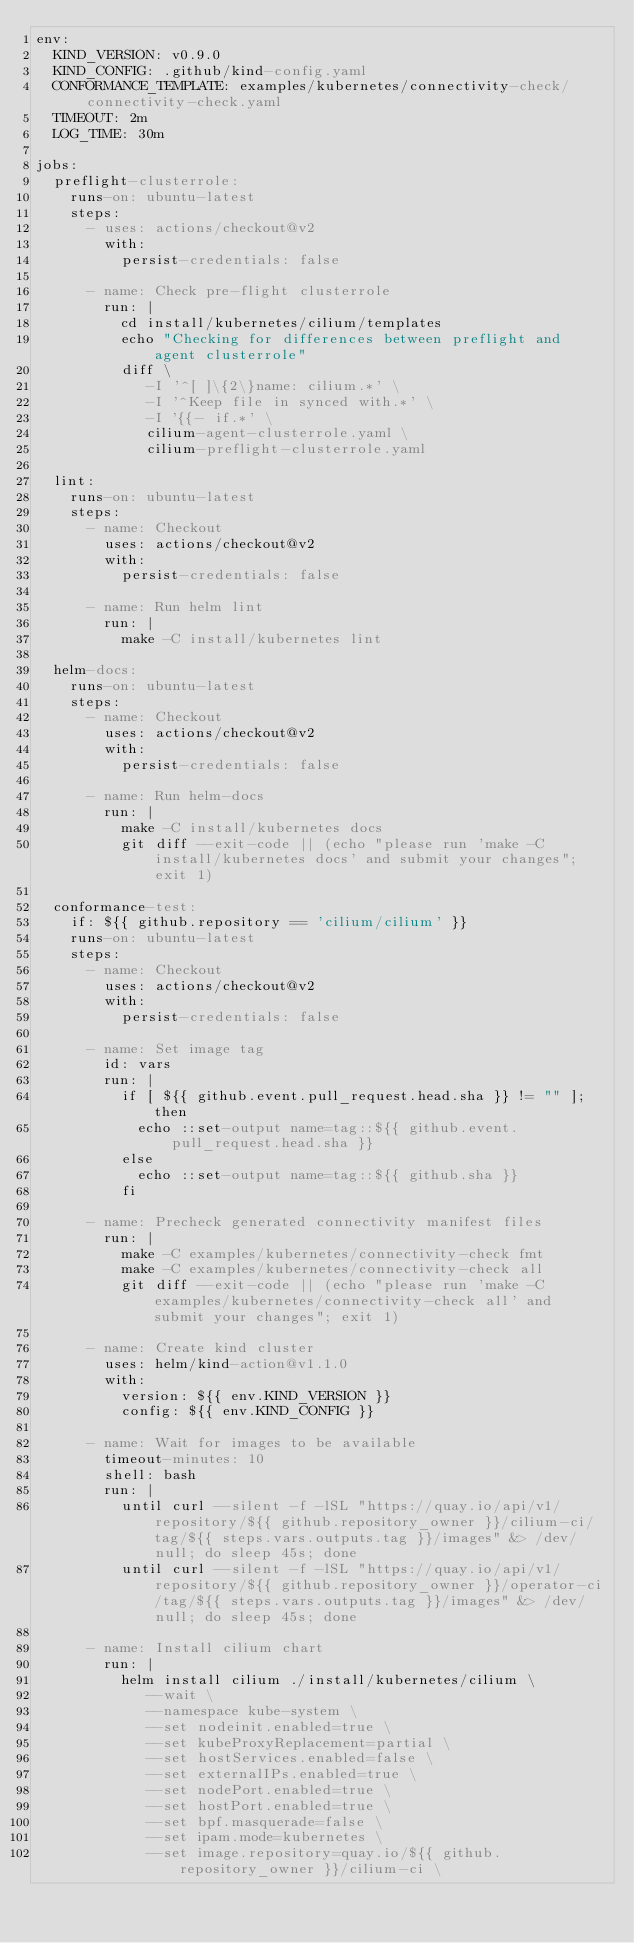<code> <loc_0><loc_0><loc_500><loc_500><_YAML_>env:
  KIND_VERSION: v0.9.0
  KIND_CONFIG: .github/kind-config.yaml
  CONFORMANCE_TEMPLATE: examples/kubernetes/connectivity-check/connectivity-check.yaml
  TIMEOUT: 2m
  LOG_TIME: 30m

jobs:
  preflight-clusterrole:
    runs-on: ubuntu-latest
    steps:
      - uses: actions/checkout@v2
        with:
          persist-credentials: false

      - name: Check pre-flight clusterrole
        run: |
          cd install/kubernetes/cilium/templates
          echo "Checking for differences between preflight and agent clusterrole"
          diff \
             -I '^[ ]\{2\}name: cilium.*' \
             -I '^Keep file in synced with.*' \
             -I '{{- if.*' \
             cilium-agent-clusterrole.yaml \
             cilium-preflight-clusterrole.yaml

  lint:
    runs-on: ubuntu-latest
    steps:
      - name: Checkout
        uses: actions/checkout@v2
        with:
          persist-credentials: false

      - name: Run helm lint
        run: |
          make -C install/kubernetes lint

  helm-docs:
    runs-on: ubuntu-latest
    steps:
      - name: Checkout
        uses: actions/checkout@v2
        with:
          persist-credentials: false

      - name: Run helm-docs
        run: |
          make -C install/kubernetes docs
          git diff --exit-code || (echo "please run 'make -C install/kubernetes docs' and submit your changes"; exit 1)

  conformance-test:
    if: ${{ github.repository == 'cilium/cilium' }}
    runs-on: ubuntu-latest
    steps:
      - name: Checkout
        uses: actions/checkout@v2
        with:
          persist-credentials: false

      - name: Set image tag
        id: vars
        run: |
          if [ ${{ github.event.pull_request.head.sha }} != "" ]; then
            echo ::set-output name=tag::${{ github.event.pull_request.head.sha }}
          else
            echo ::set-output name=tag::${{ github.sha }}
          fi

      - name: Precheck generated connectivity manifest files
        run: |
          make -C examples/kubernetes/connectivity-check fmt
          make -C examples/kubernetes/connectivity-check all
          git diff --exit-code || (echo "please run 'make -C examples/kubernetes/connectivity-check all' and submit your changes"; exit 1)

      - name: Create kind cluster
        uses: helm/kind-action@v1.1.0
        with:
          version: ${{ env.KIND_VERSION }}
          config: ${{ env.KIND_CONFIG }}

      - name: Wait for images to be available
        timeout-minutes: 10
        shell: bash
        run: |
          until curl --silent -f -lSL "https://quay.io/api/v1/repository/${{ github.repository_owner }}/cilium-ci/tag/${{ steps.vars.outputs.tag }}/images" &> /dev/null; do sleep 45s; done
          until curl --silent -f -lSL "https://quay.io/api/v1/repository/${{ github.repository_owner }}/operator-ci/tag/${{ steps.vars.outputs.tag }}/images" &> /dev/null; do sleep 45s; done

      - name: Install cilium chart
        run: |
          helm install cilium ./install/kubernetes/cilium \
             --wait \
             --namespace kube-system \
             --set nodeinit.enabled=true \
             --set kubeProxyReplacement=partial \
             --set hostServices.enabled=false \
             --set externalIPs.enabled=true \
             --set nodePort.enabled=true \
             --set hostPort.enabled=true \
             --set bpf.masquerade=false \
             --set ipam.mode=kubernetes \
             --set image.repository=quay.io/${{ github.repository_owner }}/cilium-ci \</code> 